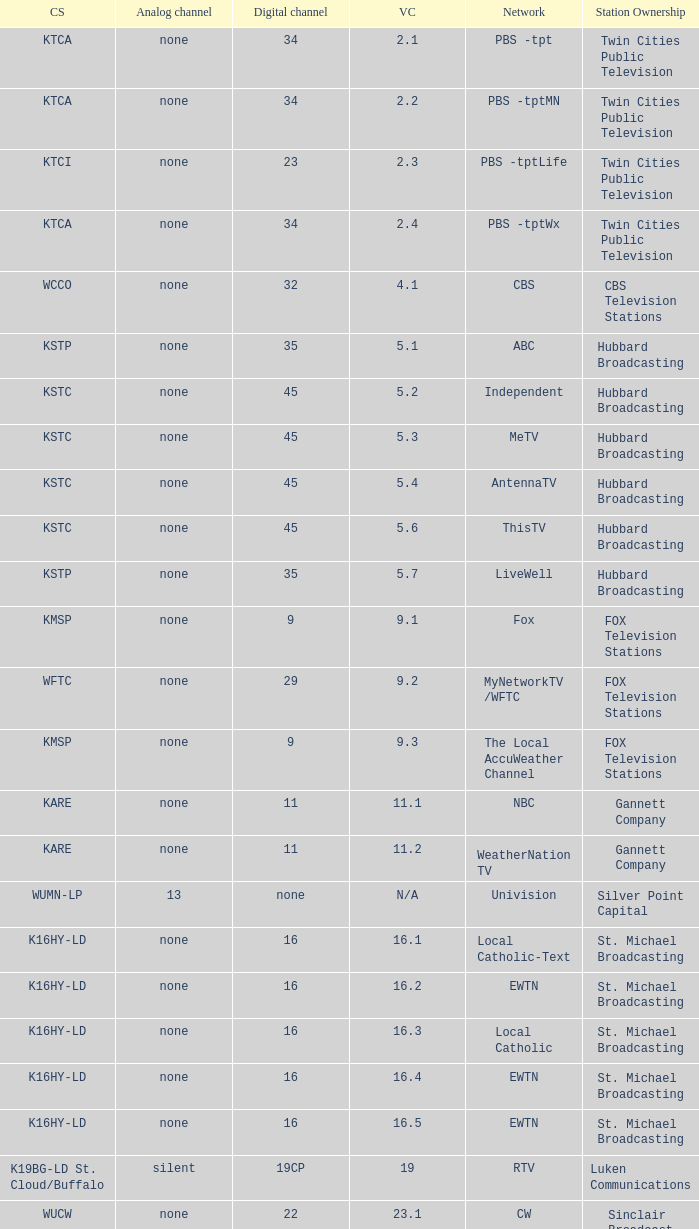Call sign of k43hb-ld is what virtual channel? 43.1. 